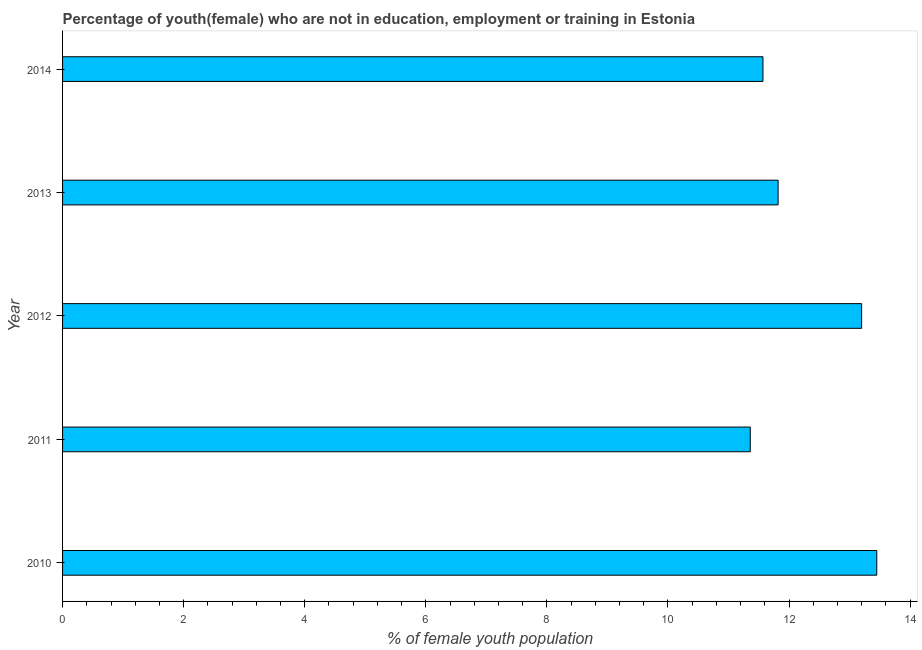Does the graph contain any zero values?
Your answer should be very brief. No. Does the graph contain grids?
Provide a short and direct response. No. What is the title of the graph?
Offer a terse response. Percentage of youth(female) who are not in education, employment or training in Estonia. What is the label or title of the X-axis?
Ensure brevity in your answer.  % of female youth population. What is the unemployed female youth population in 2010?
Your answer should be very brief. 13.45. Across all years, what is the maximum unemployed female youth population?
Ensure brevity in your answer.  13.45. Across all years, what is the minimum unemployed female youth population?
Your answer should be very brief. 11.36. In which year was the unemployed female youth population maximum?
Provide a short and direct response. 2010. In which year was the unemployed female youth population minimum?
Make the answer very short. 2011. What is the sum of the unemployed female youth population?
Provide a short and direct response. 61.4. What is the difference between the unemployed female youth population in 2011 and 2014?
Provide a short and direct response. -0.21. What is the average unemployed female youth population per year?
Offer a terse response. 12.28. What is the median unemployed female youth population?
Provide a succinct answer. 11.82. In how many years, is the unemployed female youth population greater than 13.2 %?
Give a very brief answer. 1. What is the ratio of the unemployed female youth population in 2011 to that in 2013?
Keep it short and to the point. 0.96. Is the unemployed female youth population in 2012 less than that in 2014?
Keep it short and to the point. No. What is the difference between the highest and the second highest unemployed female youth population?
Offer a very short reply. 0.25. Is the sum of the unemployed female youth population in 2010 and 2011 greater than the maximum unemployed female youth population across all years?
Provide a succinct answer. Yes. What is the difference between the highest and the lowest unemployed female youth population?
Offer a terse response. 2.09. How many years are there in the graph?
Offer a very short reply. 5. Are the values on the major ticks of X-axis written in scientific E-notation?
Offer a terse response. No. What is the % of female youth population of 2010?
Make the answer very short. 13.45. What is the % of female youth population of 2011?
Your response must be concise. 11.36. What is the % of female youth population in 2012?
Your answer should be compact. 13.2. What is the % of female youth population of 2013?
Provide a succinct answer. 11.82. What is the % of female youth population in 2014?
Provide a short and direct response. 11.57. What is the difference between the % of female youth population in 2010 and 2011?
Give a very brief answer. 2.09. What is the difference between the % of female youth population in 2010 and 2013?
Provide a succinct answer. 1.63. What is the difference between the % of female youth population in 2010 and 2014?
Make the answer very short. 1.88. What is the difference between the % of female youth population in 2011 and 2012?
Offer a very short reply. -1.84. What is the difference between the % of female youth population in 2011 and 2013?
Provide a short and direct response. -0.46. What is the difference between the % of female youth population in 2011 and 2014?
Offer a very short reply. -0.21. What is the difference between the % of female youth population in 2012 and 2013?
Offer a terse response. 1.38. What is the difference between the % of female youth population in 2012 and 2014?
Your answer should be very brief. 1.63. What is the difference between the % of female youth population in 2013 and 2014?
Provide a short and direct response. 0.25. What is the ratio of the % of female youth population in 2010 to that in 2011?
Ensure brevity in your answer.  1.18. What is the ratio of the % of female youth population in 2010 to that in 2013?
Your answer should be very brief. 1.14. What is the ratio of the % of female youth population in 2010 to that in 2014?
Make the answer very short. 1.16. What is the ratio of the % of female youth population in 2011 to that in 2012?
Your response must be concise. 0.86. What is the ratio of the % of female youth population in 2012 to that in 2013?
Your answer should be compact. 1.12. What is the ratio of the % of female youth population in 2012 to that in 2014?
Provide a succinct answer. 1.14. 